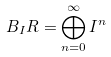<formula> <loc_0><loc_0><loc_500><loc_500>B _ { I } R = \bigoplus _ { n = 0 } ^ { \infty } I ^ { n }</formula> 